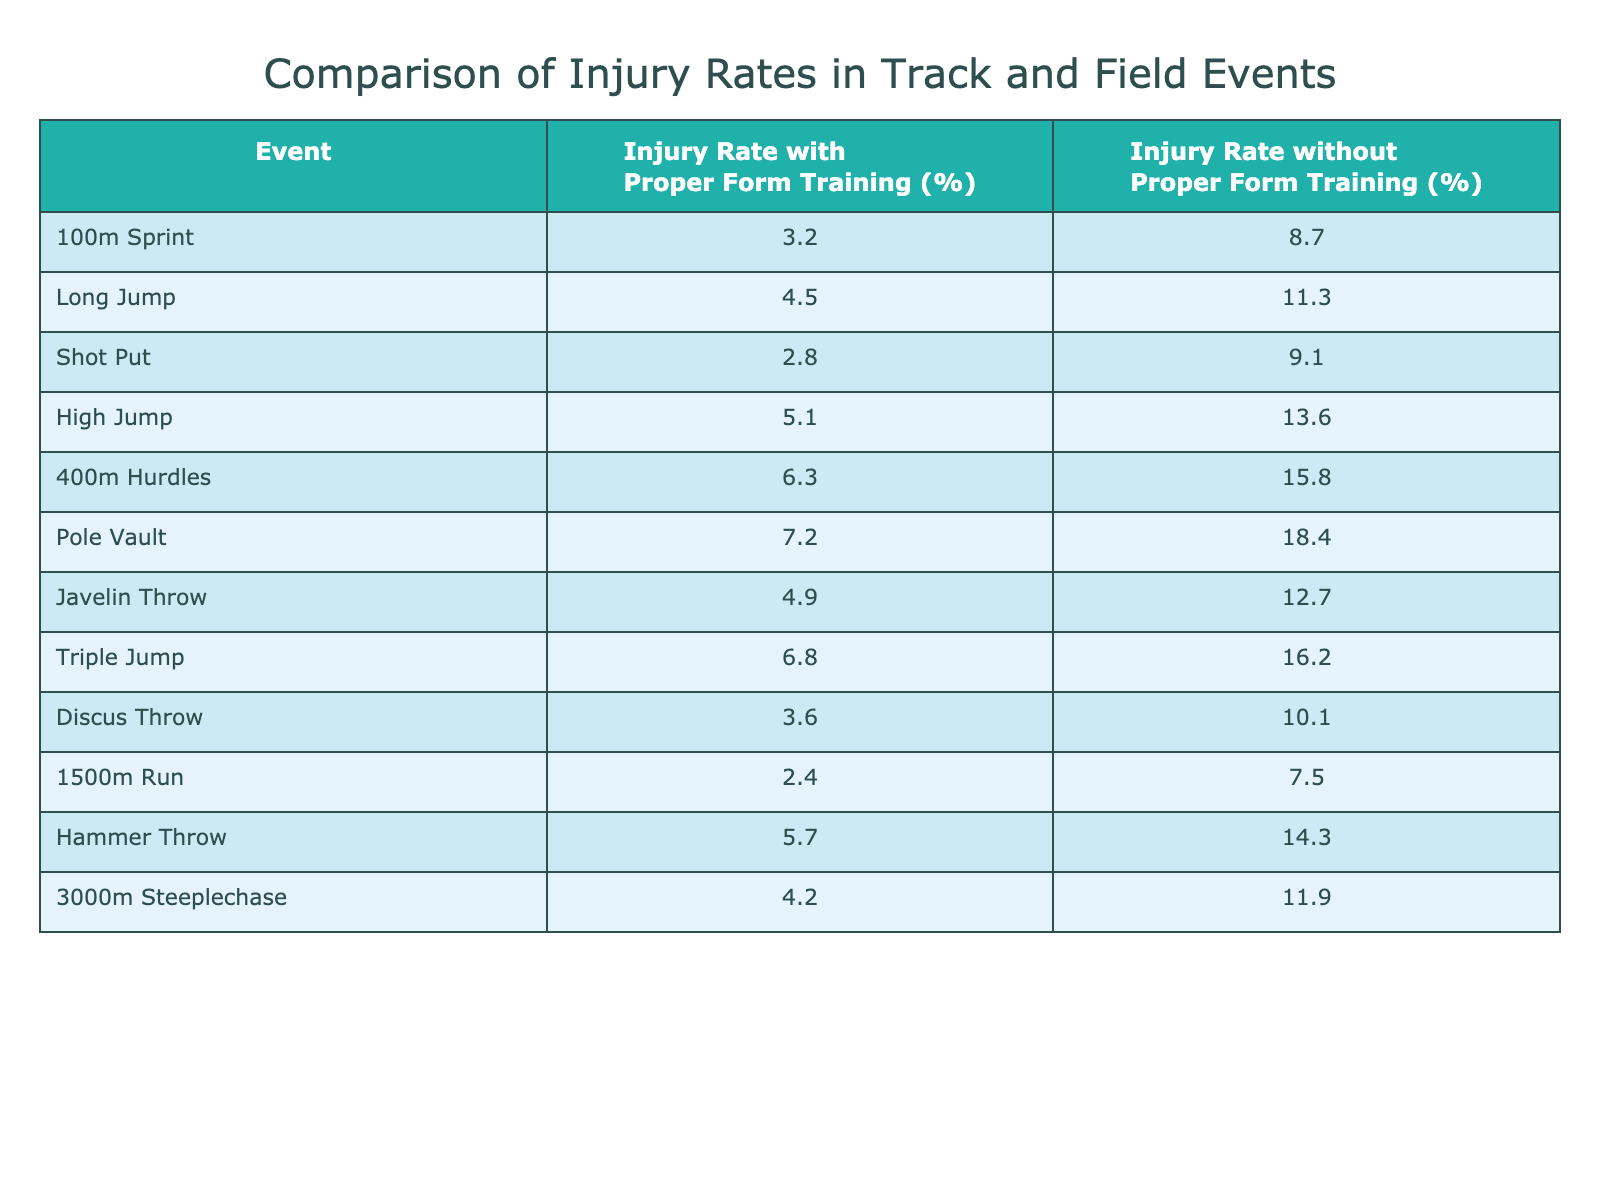What is the injury rate for the 100m sprint with proper form training? The table shows that the injury rate for the 100m sprint with proper form training is 3.2%.
Answer: 3.2% What is the difference in injury rates for Long Jump with and without proper form training? The injury rate for Long Jump with proper form training is 4.5%, and without it, it's 11.3%. The difference is 11.3% - 4.5% = 6.8%.
Answer: 6.8% Is the injury rate for the Pole Vault higher than 15% without proper form training? The table states that the injury rate for Pole Vault without proper form training is 18.4%, which is indeed higher than 15%.
Answer: Yes What event shows the largest reduction in injury rate when proper form training is implemented? For the High Jump, the injury rate without proper form training is 13.6% and with proper form training is 5.1%. The reduction is 13.6% - 5.1% = 8.5%. After checking all events, the High Jump has the largest reduction.
Answer: High Jump What is the average injury rate with proper form training across all events listed? Adding all injury rates with proper form training: (3.2 + 4.5 + 2.8 + 5.1 + 6.3 + 7.2 + 4.9 + 6.8 + 3.6 + 2.4 + 5.7 + 4.2) = 57.7%. There are 12 events, so the average is 57.7% / 12 = 4.81%.
Answer: 4.81% How many events have an injury rate under 5% with proper form training? Looking at the table, the events with an injury rate under 5% with proper form training are the 100m Sprint (3.2%), Shot Put (2.8%), 1500m Run (2.4%), and Discus Throw (3.6%). That's a total of 4 events.
Answer: 4 What is the highest injury rate without proper form training among the events listed? The highest injury rate without proper form training is found in the Pole Vault, which has an injury rate of 18.4%.
Answer: 18.4% What is the rate of injury for the Javelin Throw without proper form training compared to the Shot Put? The Javelin Throw's injury rate without proper form training is 12.7%, while for the Shot Put, it is 9.1%. The Javelin Throw has a higher injury rate by 12.7% - 9.1% = 3.6%.
Answer: Javelin Throw (higher by 3.6%) For which two events is the gap between injury rates with and without proper form training the narrowest? Checking the differences, for the Shot Put, it's 9.1% - 2.8% = 6.3%, and for the 1500m Run, it's 7.5% - 2.4% = 5.1%. The narrowest gap is between the 1500m Run and its injury rate at 5.1%.
Answer: 1500m Run 